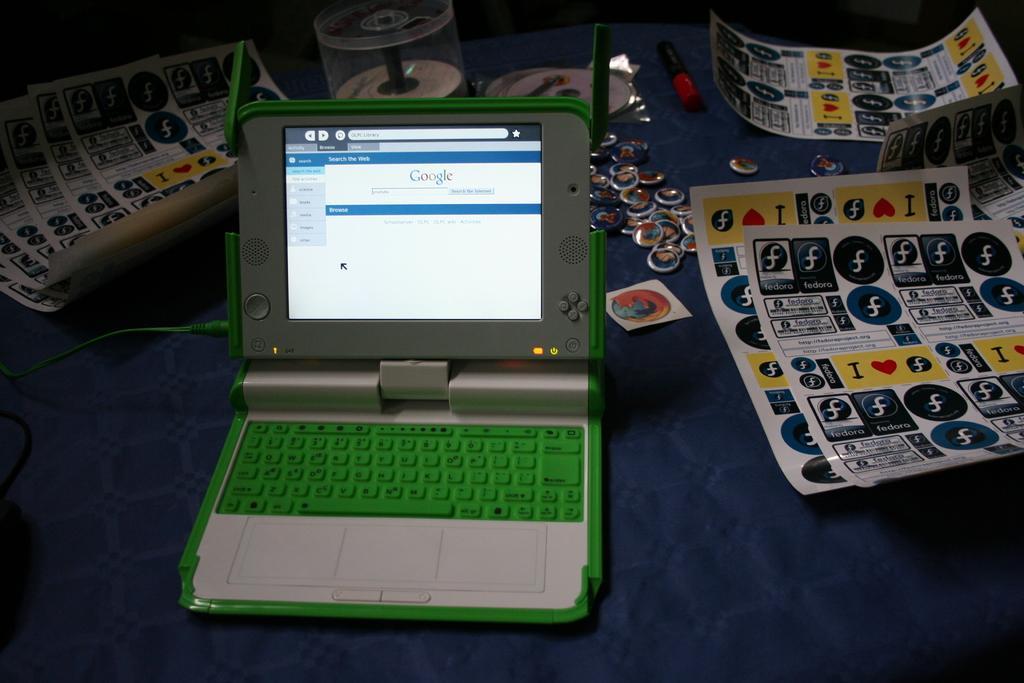What browser is the laptop using?
Make the answer very short. Google. What search engine is this person viewing?
Offer a terse response. Google. 